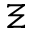Convert formula to latex. <formula><loc_0><loc_0><loc_500><loc_500>\Xi</formula> 